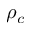<formula> <loc_0><loc_0><loc_500><loc_500>\rho _ { c }</formula> 